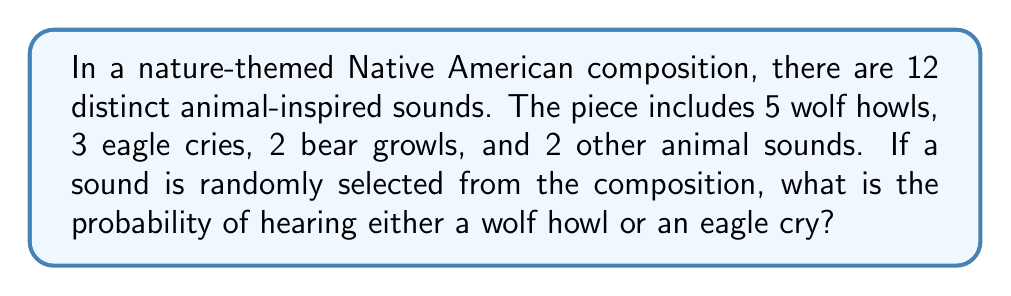Could you help me with this problem? Let's approach this step-by-step:

1) First, we need to identify the total number of sounds and the number of favorable outcomes:
   - Total sounds in the composition: 12
   - Wolf howls: 5
   - Eagle cries: 3

2) The probability of an event is calculated by dividing the number of favorable outcomes by the total number of possible outcomes:

   $P(\text{event}) = \frac{\text{favorable outcomes}}{\text{total outcomes}}$

3) In this case, we want the probability of hearing either a wolf howl or an eagle cry. This means we need to add these two categories together:
   
   Favorable outcomes = Wolf howls + Eagle cries = 5 + 3 = 8

4) Now we can calculate the probability:

   $$P(\text{wolf howl or eagle cry}) = \frac{8}{12}$$

5) This fraction can be simplified:

   $$\frac{8}{12} = \frac{2}{3}$$

Therefore, the probability of hearing either a wolf howl or an eagle cry when a sound is randomly selected from the composition is $\frac{2}{3}$.
Answer: $\frac{2}{3}$ 